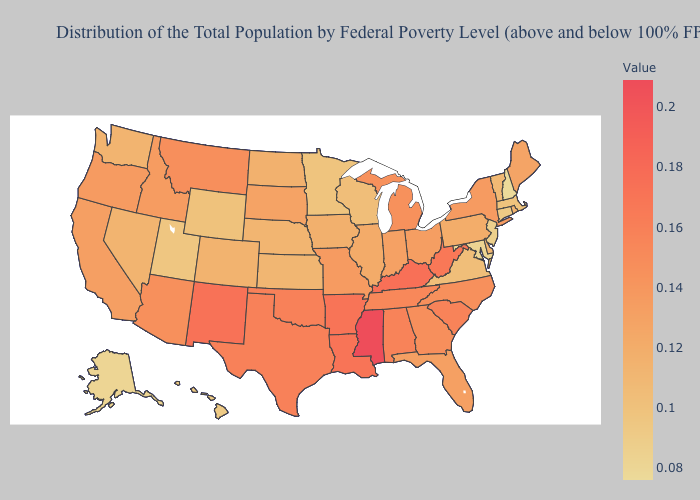Does Alaska have a higher value than Montana?
Give a very brief answer. No. Does Minnesota have the lowest value in the MidWest?
Answer briefly. Yes. Is the legend a continuous bar?
Keep it brief. Yes. Among the states that border Michigan , does Ohio have the highest value?
Answer briefly. Yes. Does Hawaii have a higher value than Kentucky?
Give a very brief answer. No. Which states hav the highest value in the South?
Answer briefly. Mississippi. Does Iowa have a higher value than Alaska?
Short answer required. Yes. 